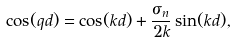<formula> <loc_0><loc_0><loc_500><loc_500>\cos ( q d ) = \cos ( k d ) + \frac { \sigma _ { n } } { 2 k } \sin ( k d ) ,</formula> 